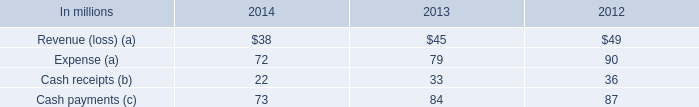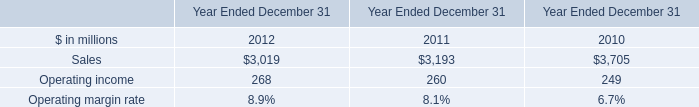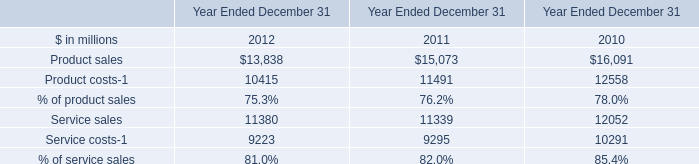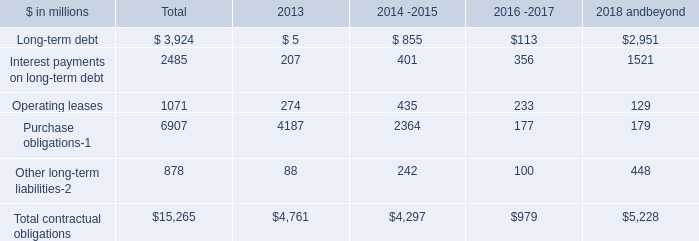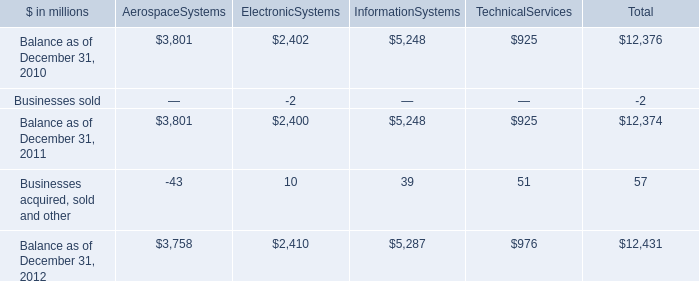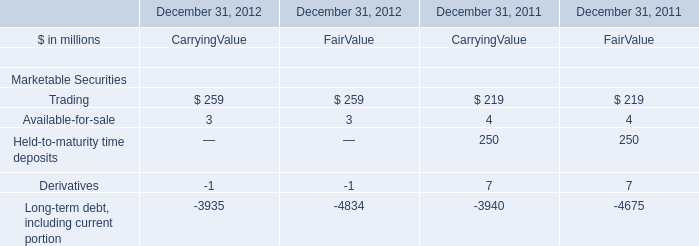What is the total amount of Service sales of Year Ended December 31 2011, and Sales of Year Ended December 31 2011 ? 
Computations: (11339.0 + 3193.0)
Answer: 14532.0. 